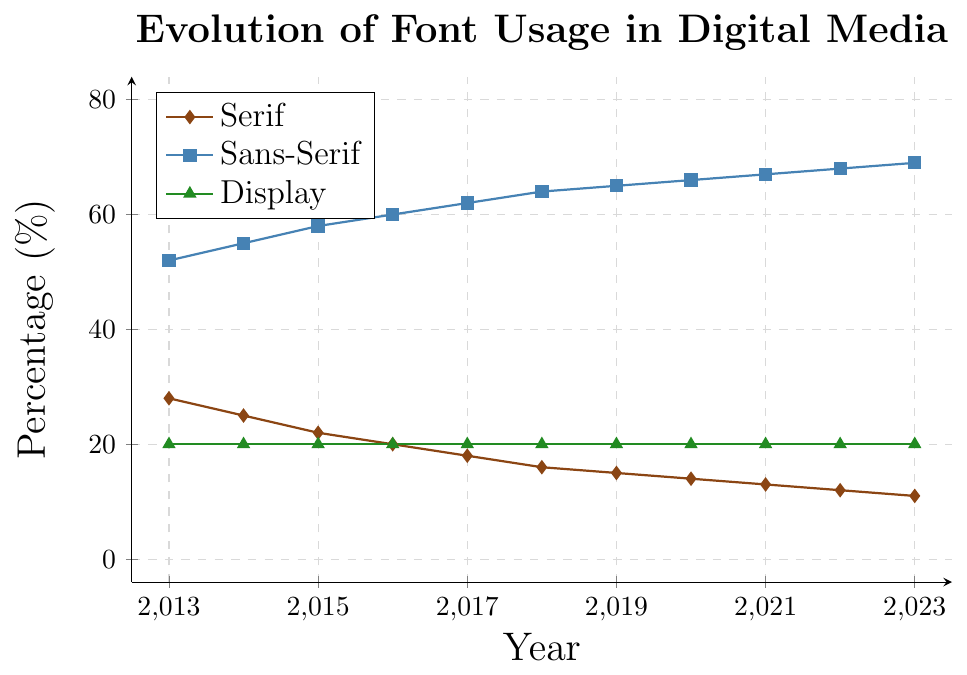What trend is noticeable for serif font usage over the decade? From the figure, the percentage usage of serif fonts decreases steadily from 28% in 2013 to 11% in 2023.
Answer: Declining Compare the usage of sans-serif and display fonts in 2020. Which was more prevalent? The figure shows that sans-serif fonts were used 66% and display fonts were used 20% in 2020. Thus, sans-serif fonts were more prevalent.
Answer: Sans-serif By how many percentage points did the usage of serif fonts decrease from 2013 to 2023? The percentage of serif font usage in 2013 was 28% and it decreased to 11% in 2023. The difference is 28% - 11% = 17%.
Answer: 17% Which font type maintained the same usage percentage over the entire decade? The figure shows the usage percentage of display fonts consistently at 20% throughout the period from 2013 to 2023.
Answer: Display What is the difference in the usage percentage between serif and sans-serif fonts in 2023? In 2023, serif fonts are used 11% and sans-serif fonts are used 69%. The difference is 69% - 11% = 58%.
Answer: 58% Calculate the average percentage usage of sans-serif fonts from 2013 to 2023. Average = (52 + 55 + 58 + 60 + 62 + 64 + 65 + 66 + 67 + 68 + 69) / 11 ≈ 61%.
Answer: 61% In which year did the usage of serif fonts fall below 20%? The figure shows that the percentage usage of serif fonts was at 20% in 2016 and fell below that in 2017.
Answer: 2017 Using visual attributes, describe the color associated with sans-serif fonts and its trend line. The sans-serif plot line is represented in blue color and shows an increasing trend from 52% in 2013 to 69% in 2023.
Answer: Blue, increasing Which font type exhibits the least variation in usage over the years? The display fonts show no variations and maintain a constant usage of 20% throughout the decade.
Answer: Display What's the overall trend for font usage in digital media for sans-serif fonts? The sans-serif fonts saw a consistent increase from 52% in 2013 to 69% in 2023.
Answer: Increasing 